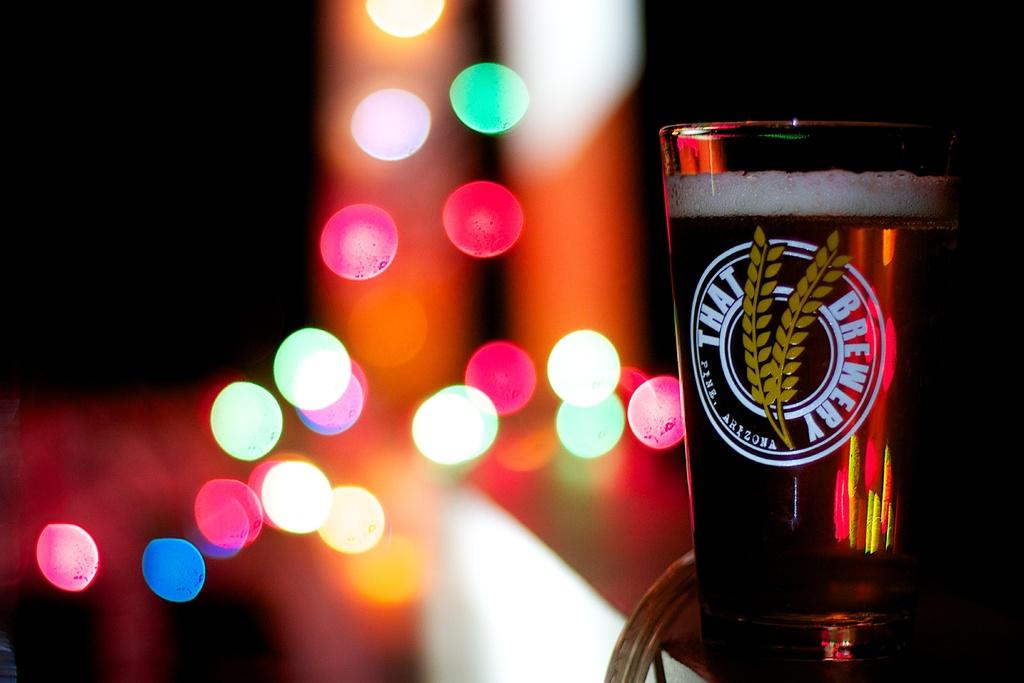<image>
Provide a brief description of the given image. A glass is imprinted with the text "That Brewery." 